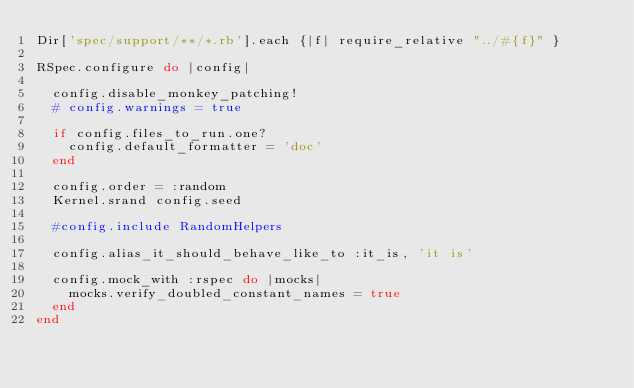Convert code to text. <code><loc_0><loc_0><loc_500><loc_500><_Ruby_>Dir['spec/support/**/*.rb'].each {|f| require_relative "../#{f}" }

RSpec.configure do |config|

  config.disable_monkey_patching!
  # config.warnings = true

  if config.files_to_run.one?
    config.default_formatter = 'doc'
  end

  config.order = :random
  Kernel.srand config.seed

  #config.include RandomHelpers

  config.alias_it_should_behave_like_to :it_is, 'it is'

  config.mock_with :rspec do |mocks|
    mocks.verify_doubled_constant_names = true
  end
end
</code> 